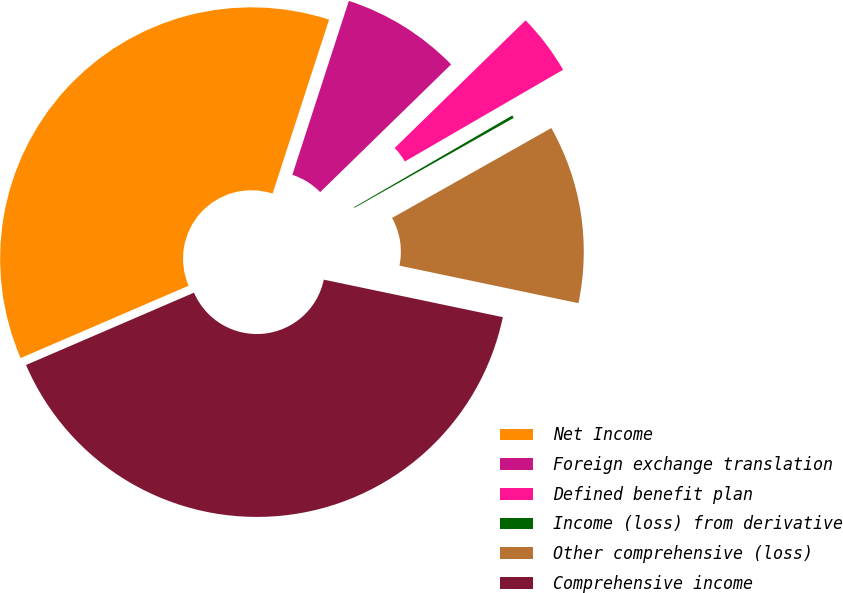Convert chart to OTSL. <chart><loc_0><loc_0><loc_500><loc_500><pie_chart><fcel>Net Income<fcel>Foreign exchange translation<fcel>Defined benefit plan<fcel>Income (loss) from derivative<fcel>Other comprehensive (loss)<fcel>Comprehensive income<nl><fcel>36.47%<fcel>7.7%<fcel>3.94%<fcel>0.18%<fcel>11.47%<fcel>40.24%<nl></chart> 